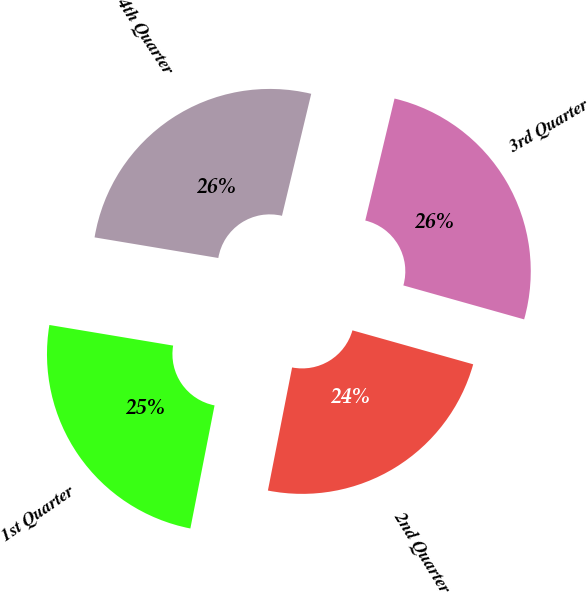Convert chart to OTSL. <chart><loc_0><loc_0><loc_500><loc_500><pie_chart><fcel>1st Quarter<fcel>2nd Quarter<fcel>3rd Quarter<fcel>4th Quarter<nl><fcel>24.54%<fcel>23.73%<fcel>25.62%<fcel>26.12%<nl></chart> 